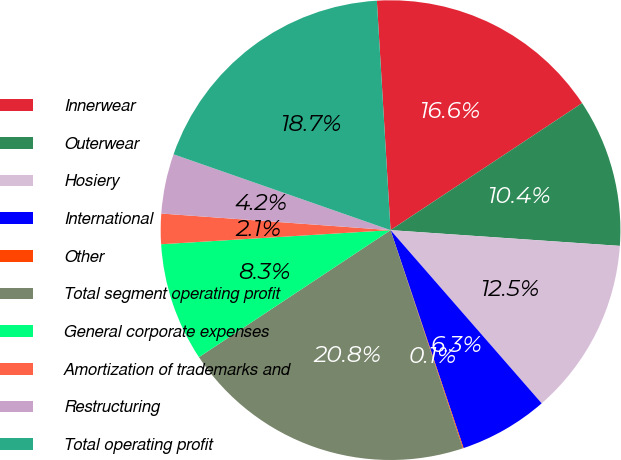Convert chart. <chart><loc_0><loc_0><loc_500><loc_500><pie_chart><fcel>Innerwear<fcel>Outerwear<fcel>Hosiery<fcel>International<fcel>Other<fcel>Total segment operating profit<fcel>General corporate expenses<fcel>Amortization of trademarks and<fcel>Restructuring<fcel>Total operating profit<nl><fcel>16.63%<fcel>10.41%<fcel>12.49%<fcel>6.27%<fcel>0.06%<fcel>20.77%<fcel>8.34%<fcel>2.13%<fcel>4.2%<fcel>18.7%<nl></chart> 